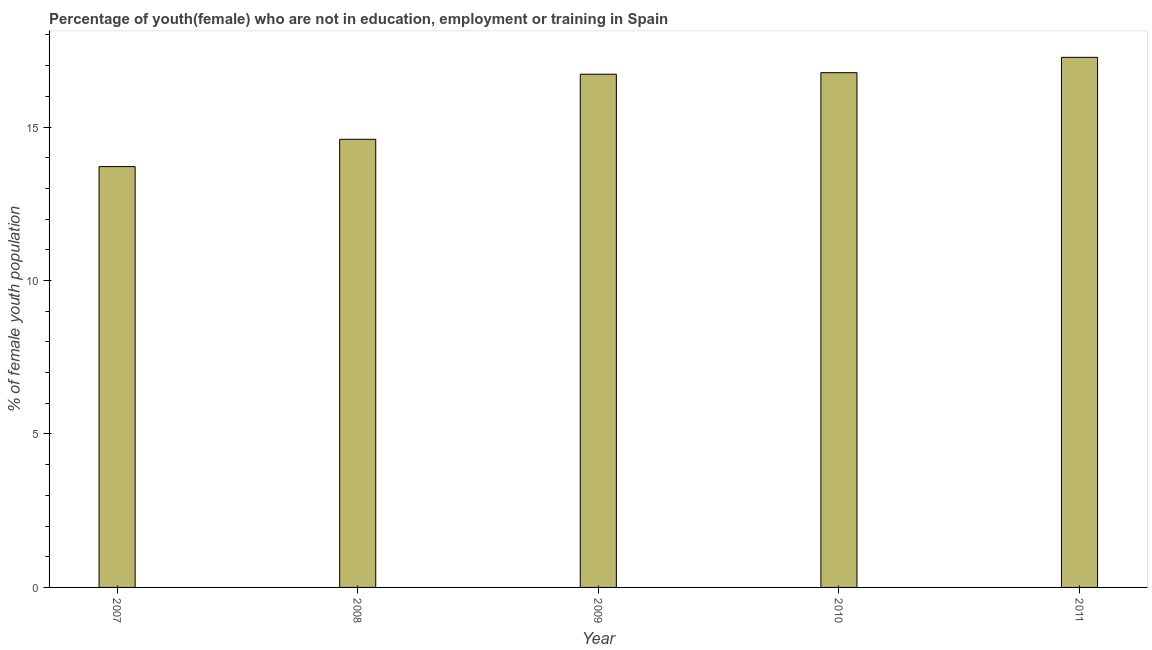Does the graph contain any zero values?
Offer a terse response. No. Does the graph contain grids?
Keep it short and to the point. No. What is the title of the graph?
Your answer should be very brief. Percentage of youth(female) who are not in education, employment or training in Spain. What is the label or title of the X-axis?
Your answer should be compact. Year. What is the label or title of the Y-axis?
Make the answer very short. % of female youth population. What is the unemployed female youth population in 2009?
Provide a short and direct response. 16.72. Across all years, what is the maximum unemployed female youth population?
Provide a short and direct response. 17.27. Across all years, what is the minimum unemployed female youth population?
Make the answer very short. 13.71. In which year was the unemployed female youth population maximum?
Keep it short and to the point. 2011. What is the sum of the unemployed female youth population?
Your answer should be very brief. 79.07. What is the difference between the unemployed female youth population in 2009 and 2011?
Your answer should be compact. -0.55. What is the average unemployed female youth population per year?
Offer a very short reply. 15.81. What is the median unemployed female youth population?
Ensure brevity in your answer.  16.72. In how many years, is the unemployed female youth population greater than 10 %?
Ensure brevity in your answer.  5. Do a majority of the years between 2011 and 2010 (inclusive) have unemployed female youth population greater than 16 %?
Provide a succinct answer. No. What is the ratio of the unemployed female youth population in 2009 to that in 2010?
Offer a terse response. 1. Is the unemployed female youth population in 2007 less than that in 2008?
Provide a short and direct response. Yes. What is the difference between the highest and the second highest unemployed female youth population?
Provide a succinct answer. 0.5. Is the sum of the unemployed female youth population in 2009 and 2010 greater than the maximum unemployed female youth population across all years?
Offer a terse response. Yes. What is the difference between the highest and the lowest unemployed female youth population?
Provide a succinct answer. 3.56. How many bars are there?
Your answer should be very brief. 5. How many years are there in the graph?
Your response must be concise. 5. Are the values on the major ticks of Y-axis written in scientific E-notation?
Make the answer very short. No. What is the % of female youth population of 2007?
Your answer should be compact. 13.71. What is the % of female youth population in 2008?
Provide a short and direct response. 14.6. What is the % of female youth population of 2009?
Offer a terse response. 16.72. What is the % of female youth population of 2010?
Your answer should be compact. 16.77. What is the % of female youth population in 2011?
Offer a terse response. 17.27. What is the difference between the % of female youth population in 2007 and 2008?
Keep it short and to the point. -0.89. What is the difference between the % of female youth population in 2007 and 2009?
Keep it short and to the point. -3.01. What is the difference between the % of female youth population in 2007 and 2010?
Give a very brief answer. -3.06. What is the difference between the % of female youth population in 2007 and 2011?
Your answer should be very brief. -3.56. What is the difference between the % of female youth population in 2008 and 2009?
Keep it short and to the point. -2.12. What is the difference between the % of female youth population in 2008 and 2010?
Your response must be concise. -2.17. What is the difference between the % of female youth population in 2008 and 2011?
Your response must be concise. -2.67. What is the difference between the % of female youth population in 2009 and 2010?
Keep it short and to the point. -0.05. What is the difference between the % of female youth population in 2009 and 2011?
Give a very brief answer. -0.55. What is the difference between the % of female youth population in 2010 and 2011?
Your answer should be compact. -0.5. What is the ratio of the % of female youth population in 2007 to that in 2008?
Provide a short and direct response. 0.94. What is the ratio of the % of female youth population in 2007 to that in 2009?
Your answer should be compact. 0.82. What is the ratio of the % of female youth population in 2007 to that in 2010?
Your answer should be very brief. 0.82. What is the ratio of the % of female youth population in 2007 to that in 2011?
Provide a short and direct response. 0.79. What is the ratio of the % of female youth population in 2008 to that in 2009?
Offer a terse response. 0.87. What is the ratio of the % of female youth population in 2008 to that in 2010?
Provide a succinct answer. 0.87. What is the ratio of the % of female youth population in 2008 to that in 2011?
Offer a very short reply. 0.84. What is the ratio of the % of female youth population in 2009 to that in 2010?
Make the answer very short. 1. What is the ratio of the % of female youth population in 2010 to that in 2011?
Your answer should be very brief. 0.97. 